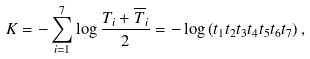Convert formula to latex. <formula><loc_0><loc_0><loc_500><loc_500>K = - \sum _ { i = 1 } ^ { 7 } \log \frac { T _ { i } + \overline { T } _ { i } } { 2 } = - \log \left ( t _ { 1 } t _ { 2 } t _ { 3 } t _ { 4 } t _ { 5 } t _ { 6 } t _ { 7 } \right ) ,</formula> 